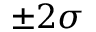Convert formula to latex. <formula><loc_0><loc_0><loc_500><loc_500>\pm 2 \sigma</formula> 